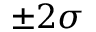Convert formula to latex. <formula><loc_0><loc_0><loc_500><loc_500>\pm 2 \sigma</formula> 